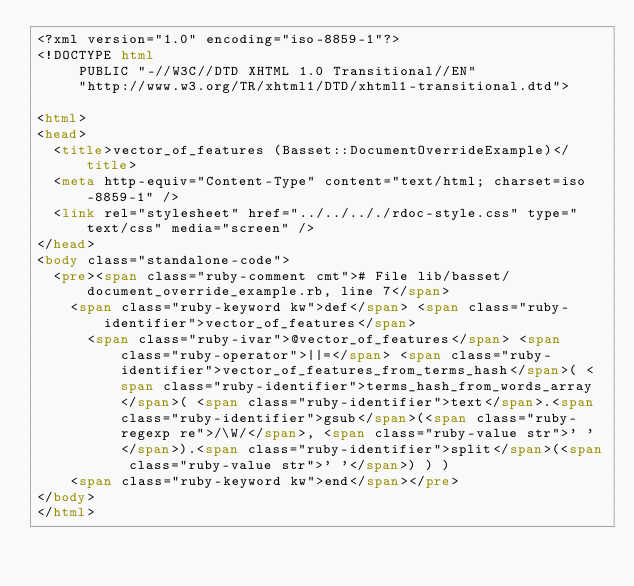<code> <loc_0><loc_0><loc_500><loc_500><_HTML_><?xml version="1.0" encoding="iso-8859-1"?>
<!DOCTYPE html 
     PUBLIC "-//W3C//DTD XHTML 1.0 Transitional//EN"
     "http://www.w3.org/TR/xhtml1/DTD/xhtml1-transitional.dtd">

<html>
<head>
  <title>vector_of_features (Basset::DocumentOverrideExample)</title>
  <meta http-equiv="Content-Type" content="text/html; charset=iso-8859-1" />
  <link rel="stylesheet" href="../../.././rdoc-style.css" type="text/css" media="screen" />
</head>
<body class="standalone-code">
  <pre><span class="ruby-comment cmt"># File lib/basset/document_override_example.rb, line 7</span>
    <span class="ruby-keyword kw">def</span> <span class="ruby-identifier">vector_of_features</span>
      <span class="ruby-ivar">@vector_of_features</span> <span class="ruby-operator">||=</span> <span class="ruby-identifier">vector_of_features_from_terms_hash</span>( <span class="ruby-identifier">terms_hash_from_words_array</span>( <span class="ruby-identifier">text</span>.<span class="ruby-identifier">gsub</span>(<span class="ruby-regexp re">/\W/</span>, <span class="ruby-value str">' '</span>).<span class="ruby-identifier">split</span>(<span class="ruby-value str">' '</span>) ) )
    <span class="ruby-keyword kw">end</span></pre>
</body>
</html></code> 